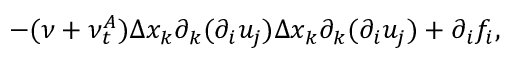Convert formula to latex. <formula><loc_0><loc_0><loc_500><loc_500>- ( \nu + \nu _ { t } ^ { A } ) \Delta x _ { k } \partial _ { k } ( \partial _ { i } u _ { j } ) \Delta x _ { k } \partial _ { k } ( \partial _ { i } u _ { j } ) + \partial _ { i } f _ { i } ,</formula> 